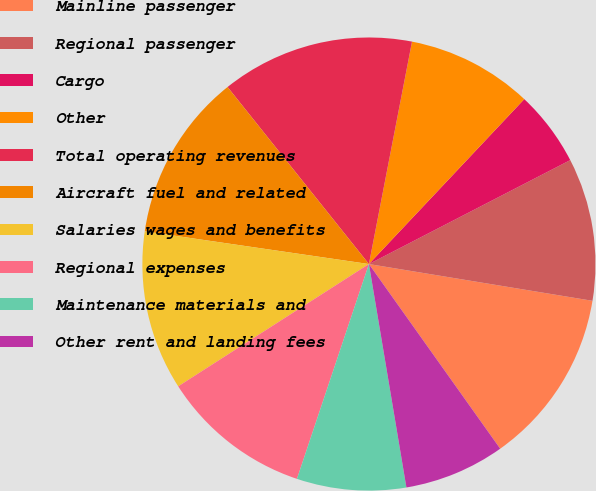Convert chart to OTSL. <chart><loc_0><loc_0><loc_500><loc_500><pie_chart><fcel>Mainline passenger<fcel>Regional passenger<fcel>Cargo<fcel>Other<fcel>Total operating revenues<fcel>Aircraft fuel and related<fcel>Salaries wages and benefits<fcel>Regional expenses<fcel>Maintenance materials and<fcel>Other rent and landing fees<nl><fcel>12.57%<fcel>10.18%<fcel>5.39%<fcel>8.98%<fcel>13.77%<fcel>11.97%<fcel>11.38%<fcel>10.78%<fcel>7.79%<fcel>7.19%<nl></chart> 